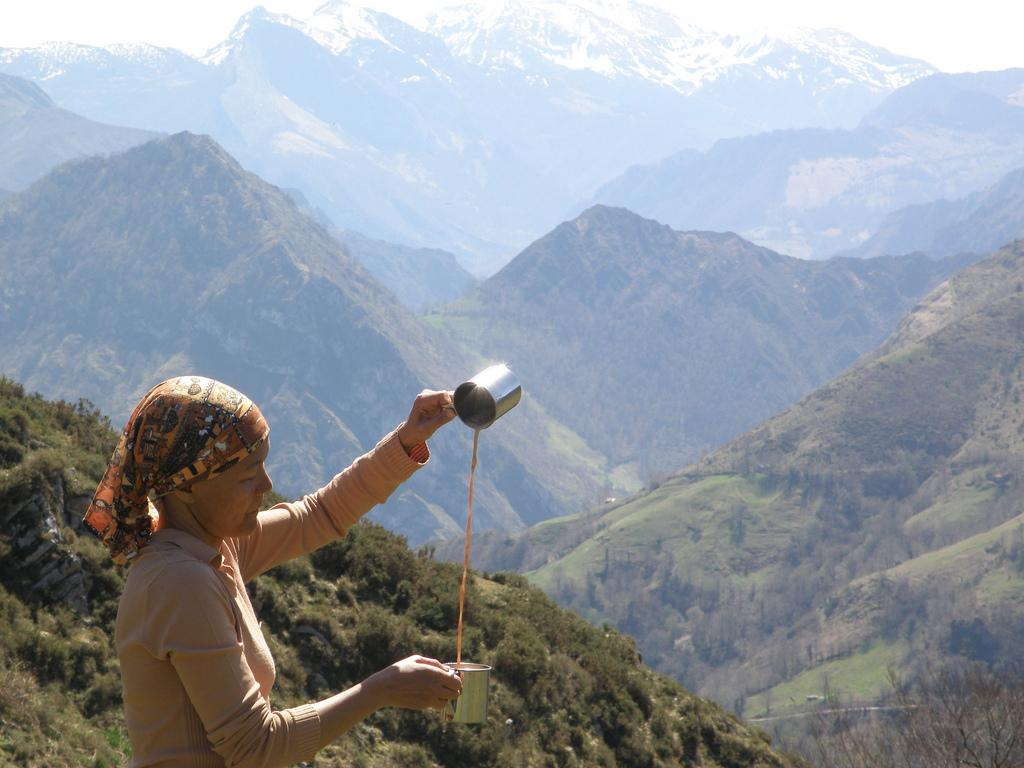What is the main subject in the image? There is a woman standing in the image. What can be seen in the background of the image? There are mountains in the background of the image. Are there any other natural elements present in the image? Yes, trees are present in the image. How is the weather in the image? The sky is clear in the image, suggesting good weather. What is the condition of the mountains in the image? There is snow on the mountains in the image. What type of patch can be seen on the woman's clothing in the image? There is no patch visible on the woman's clothing in the image. 